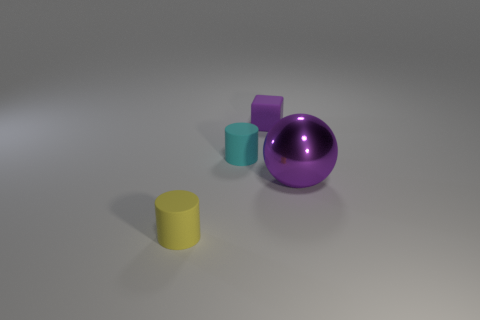Add 2 small rubber things. How many objects exist? 6 Add 1 matte blocks. How many matte blocks are left? 2 Add 4 gray matte cylinders. How many gray matte cylinders exist? 4 Subtract 0 cyan balls. How many objects are left? 4 Subtract all purple metallic objects. Subtract all small purple matte objects. How many objects are left? 2 